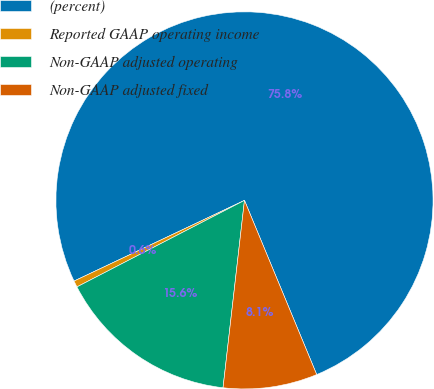Convert chart to OTSL. <chart><loc_0><loc_0><loc_500><loc_500><pie_chart><fcel>(percent)<fcel>Reported GAAP operating income<fcel>Non-GAAP adjusted operating<fcel>Non-GAAP adjusted fixed<nl><fcel>75.78%<fcel>0.55%<fcel>15.6%<fcel>8.07%<nl></chart> 